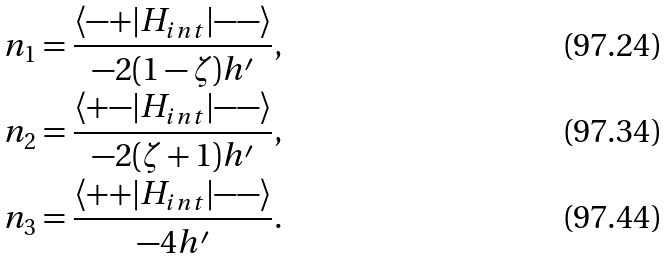<formula> <loc_0><loc_0><loc_500><loc_500>n _ { 1 } = \frac { \langle { - + } | H _ { i n t } | { - - } \rangle } { - 2 ( 1 - \zeta ) h ^ { \prime } } , \\ n _ { 2 } = \frac { \langle { + - } | H _ { i n t } | { - - } \rangle } { - 2 ( \zeta + 1 ) h ^ { \prime } } , \\ n _ { 3 } = \frac { \langle { + + } | H _ { i n t } | { - - } \rangle } { - 4 h ^ { \prime } } .</formula> 